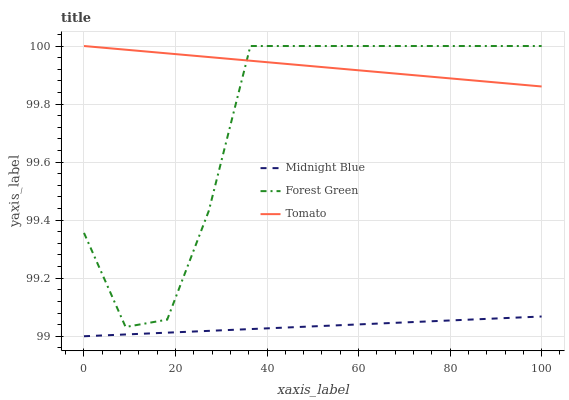Does Midnight Blue have the minimum area under the curve?
Answer yes or no. Yes. Does Tomato have the maximum area under the curve?
Answer yes or no. Yes. Does Forest Green have the minimum area under the curve?
Answer yes or no. No. Does Forest Green have the maximum area under the curve?
Answer yes or no. No. Is Midnight Blue the smoothest?
Answer yes or no. Yes. Is Forest Green the roughest?
Answer yes or no. Yes. Is Forest Green the smoothest?
Answer yes or no. No. Is Midnight Blue the roughest?
Answer yes or no. No. Does Midnight Blue have the lowest value?
Answer yes or no. Yes. Does Forest Green have the lowest value?
Answer yes or no. No. Does Forest Green have the highest value?
Answer yes or no. Yes. Does Midnight Blue have the highest value?
Answer yes or no. No. Is Midnight Blue less than Forest Green?
Answer yes or no. Yes. Is Forest Green greater than Midnight Blue?
Answer yes or no. Yes. Does Forest Green intersect Tomato?
Answer yes or no. Yes. Is Forest Green less than Tomato?
Answer yes or no. No. Is Forest Green greater than Tomato?
Answer yes or no. No. Does Midnight Blue intersect Forest Green?
Answer yes or no. No. 